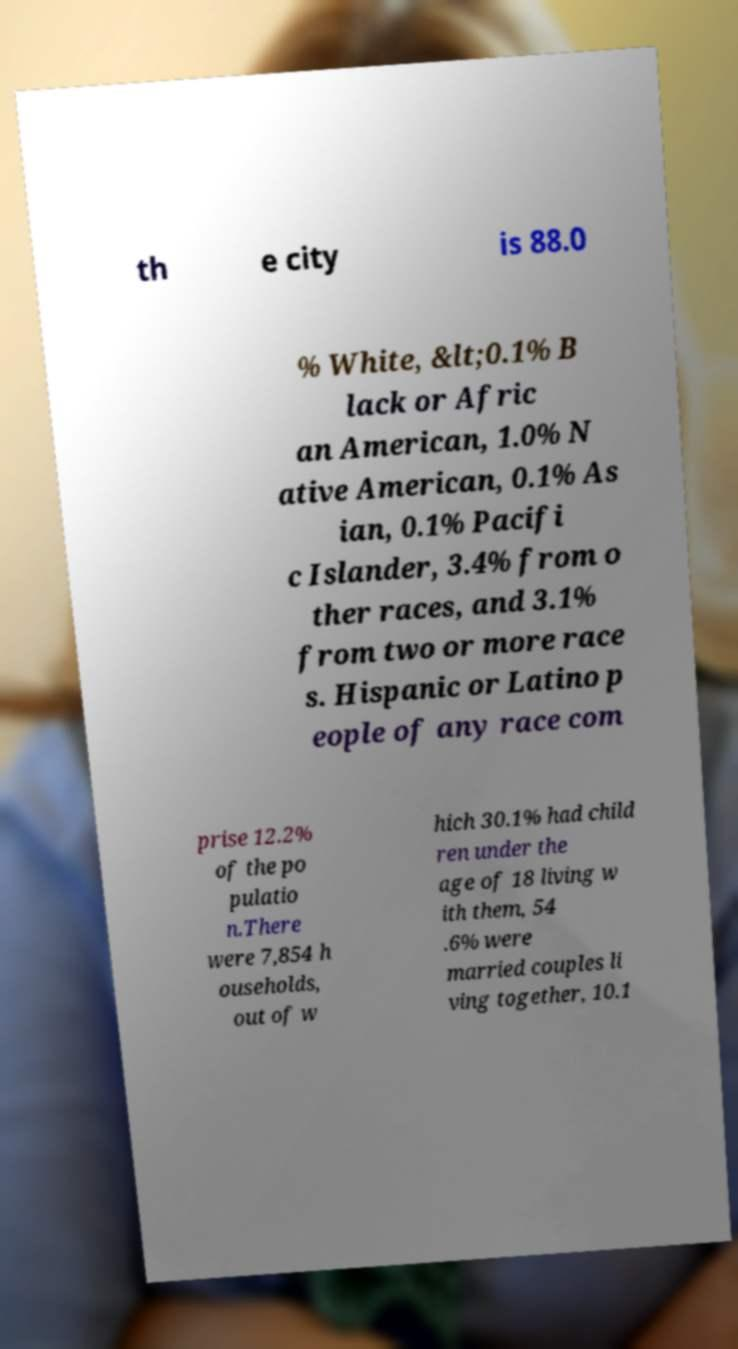There's text embedded in this image that I need extracted. Can you transcribe it verbatim? th e city is 88.0 % White, &lt;0.1% B lack or Afric an American, 1.0% N ative American, 0.1% As ian, 0.1% Pacifi c Islander, 3.4% from o ther races, and 3.1% from two or more race s. Hispanic or Latino p eople of any race com prise 12.2% of the po pulatio n.There were 7,854 h ouseholds, out of w hich 30.1% had child ren under the age of 18 living w ith them, 54 .6% were married couples li ving together, 10.1 